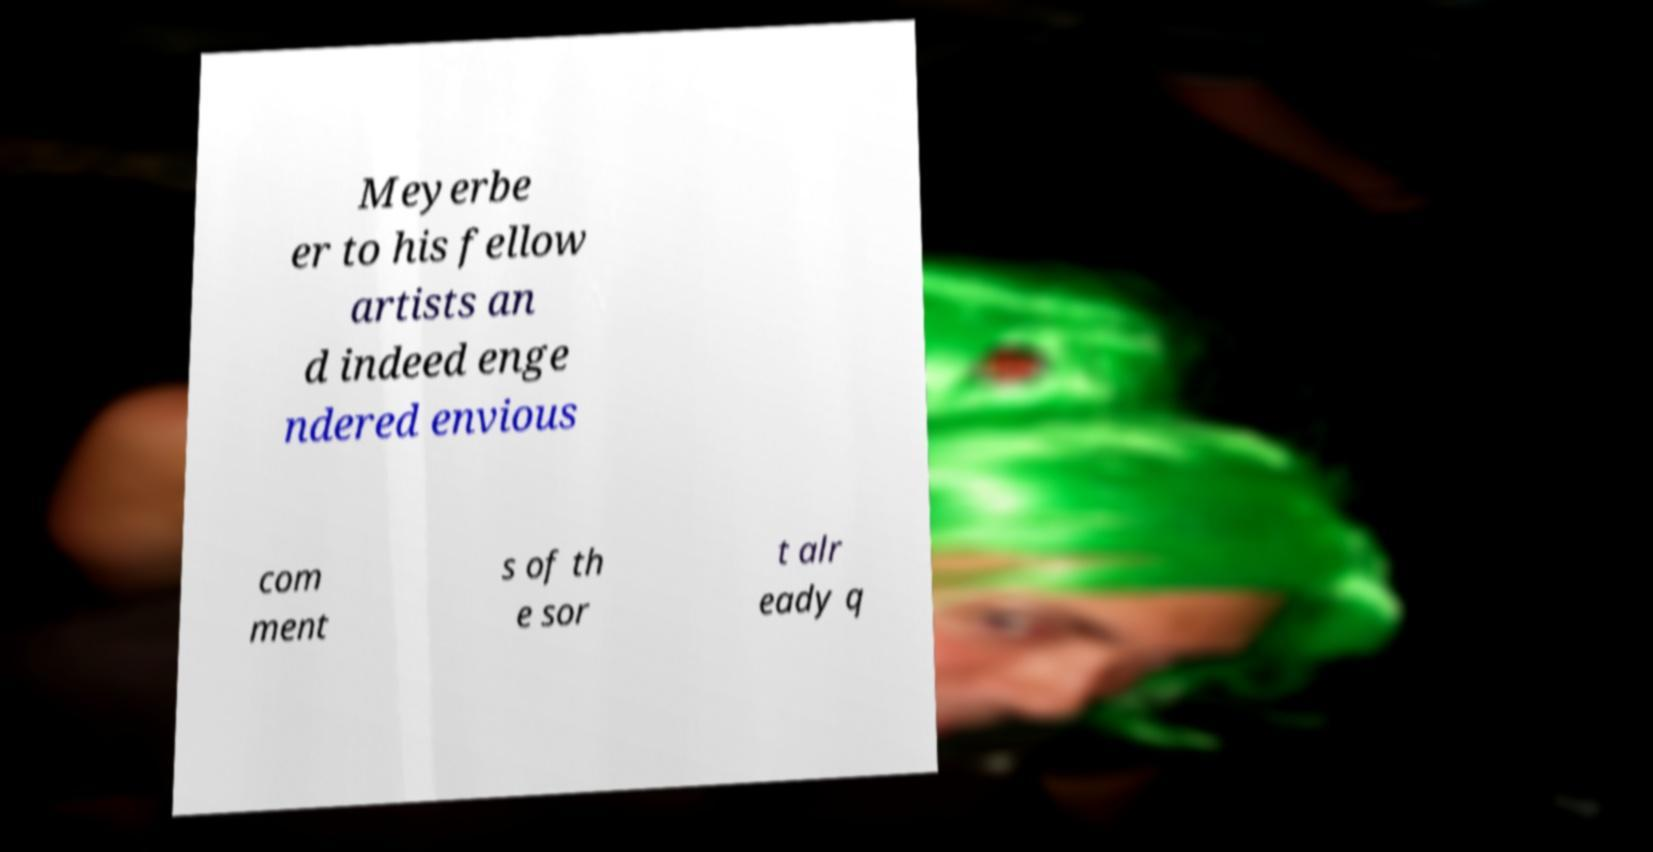Could you extract and type out the text from this image? Meyerbe er to his fellow artists an d indeed enge ndered envious com ment s of th e sor t alr eady q 